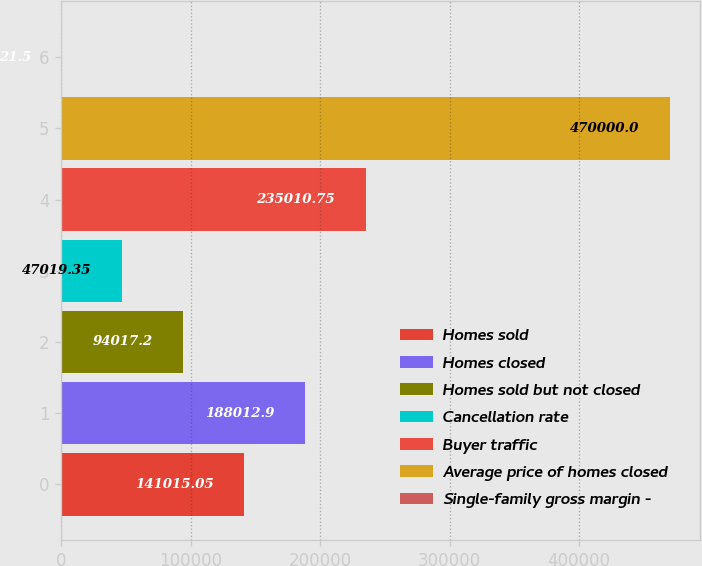Convert chart. <chart><loc_0><loc_0><loc_500><loc_500><bar_chart><fcel>Homes sold<fcel>Homes closed<fcel>Homes sold but not closed<fcel>Cancellation rate<fcel>Buyer traffic<fcel>Average price of homes closed<fcel>Single-family gross margin -<nl><fcel>141015<fcel>188013<fcel>94017.2<fcel>47019.3<fcel>235011<fcel>470000<fcel>21.5<nl></chart> 